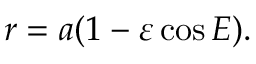<formula> <loc_0><loc_0><loc_500><loc_500>r = a ( 1 - \varepsilon \cos E ) .</formula> 